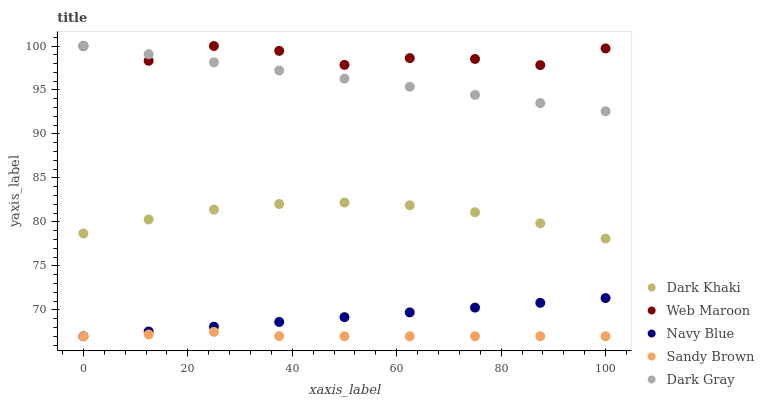Does Sandy Brown have the minimum area under the curve?
Answer yes or no. Yes. Does Web Maroon have the maximum area under the curve?
Answer yes or no. Yes. Does Navy Blue have the minimum area under the curve?
Answer yes or no. No. Does Navy Blue have the maximum area under the curve?
Answer yes or no. No. Is Navy Blue the smoothest?
Answer yes or no. Yes. Is Web Maroon the roughest?
Answer yes or no. Yes. Is Web Maroon the smoothest?
Answer yes or no. No. Is Navy Blue the roughest?
Answer yes or no. No. Does Navy Blue have the lowest value?
Answer yes or no. Yes. Does Web Maroon have the lowest value?
Answer yes or no. No. Does Dark Gray have the highest value?
Answer yes or no. Yes. Does Navy Blue have the highest value?
Answer yes or no. No. Is Navy Blue less than Dark Khaki?
Answer yes or no. Yes. Is Web Maroon greater than Navy Blue?
Answer yes or no. Yes. Does Navy Blue intersect Sandy Brown?
Answer yes or no. Yes. Is Navy Blue less than Sandy Brown?
Answer yes or no. No. Is Navy Blue greater than Sandy Brown?
Answer yes or no. No. Does Navy Blue intersect Dark Khaki?
Answer yes or no. No. 